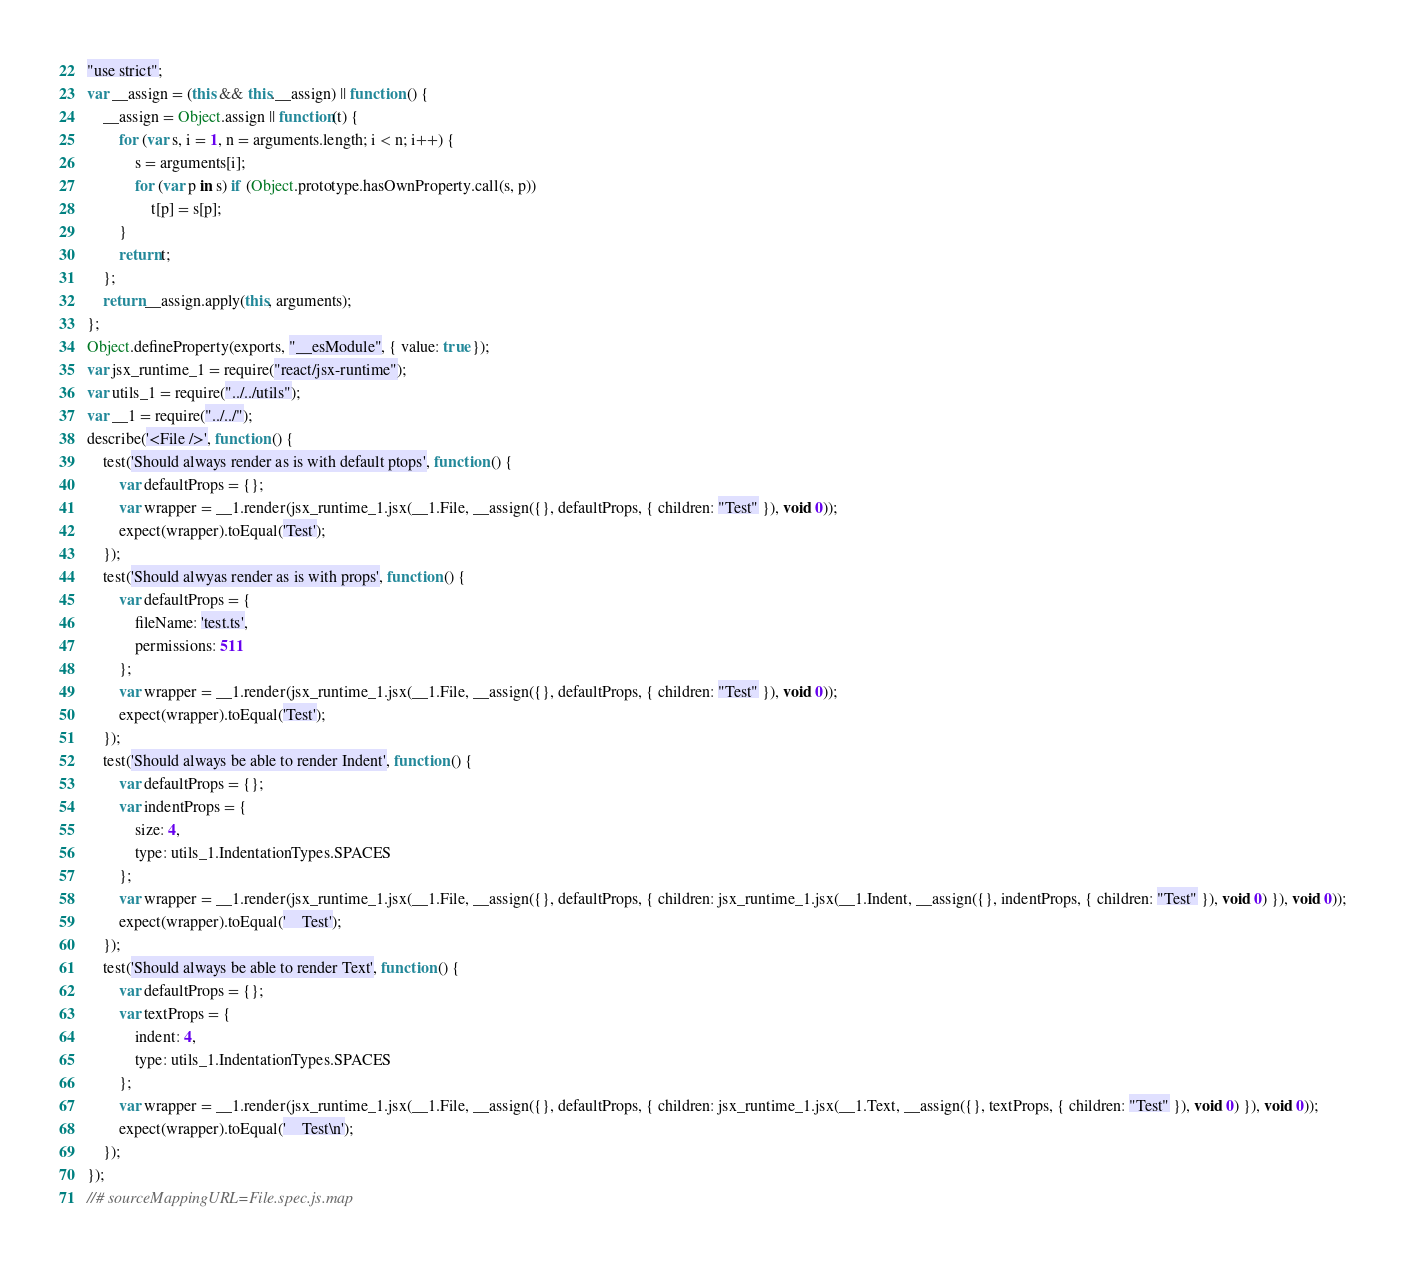Convert code to text. <code><loc_0><loc_0><loc_500><loc_500><_JavaScript_>"use strict";
var __assign = (this && this.__assign) || function () {
    __assign = Object.assign || function(t) {
        for (var s, i = 1, n = arguments.length; i < n; i++) {
            s = arguments[i];
            for (var p in s) if (Object.prototype.hasOwnProperty.call(s, p))
                t[p] = s[p];
        }
        return t;
    };
    return __assign.apply(this, arguments);
};
Object.defineProperty(exports, "__esModule", { value: true });
var jsx_runtime_1 = require("react/jsx-runtime");
var utils_1 = require("../../utils");
var __1 = require("../../");
describe('<File />', function () {
    test('Should always render as is with default ptops', function () {
        var defaultProps = {};
        var wrapper = __1.render(jsx_runtime_1.jsx(__1.File, __assign({}, defaultProps, { children: "Test" }), void 0));
        expect(wrapper).toEqual('Test');
    });
    test('Should alwyas render as is with props', function () {
        var defaultProps = {
            fileName: 'test.ts',
            permissions: 511
        };
        var wrapper = __1.render(jsx_runtime_1.jsx(__1.File, __assign({}, defaultProps, { children: "Test" }), void 0));
        expect(wrapper).toEqual('Test');
    });
    test('Should always be able to render Indent', function () {
        var defaultProps = {};
        var indentProps = {
            size: 4,
            type: utils_1.IndentationTypes.SPACES
        };
        var wrapper = __1.render(jsx_runtime_1.jsx(__1.File, __assign({}, defaultProps, { children: jsx_runtime_1.jsx(__1.Indent, __assign({}, indentProps, { children: "Test" }), void 0) }), void 0));
        expect(wrapper).toEqual('    Test');
    });
    test('Should always be able to render Text', function () {
        var defaultProps = {};
        var textProps = {
            indent: 4,
            type: utils_1.IndentationTypes.SPACES
        };
        var wrapper = __1.render(jsx_runtime_1.jsx(__1.File, __assign({}, defaultProps, { children: jsx_runtime_1.jsx(__1.Text, __assign({}, textProps, { children: "Test" }), void 0) }), void 0));
        expect(wrapper).toEqual('    Test\n');
    });
});
//# sourceMappingURL=File.spec.js.map</code> 